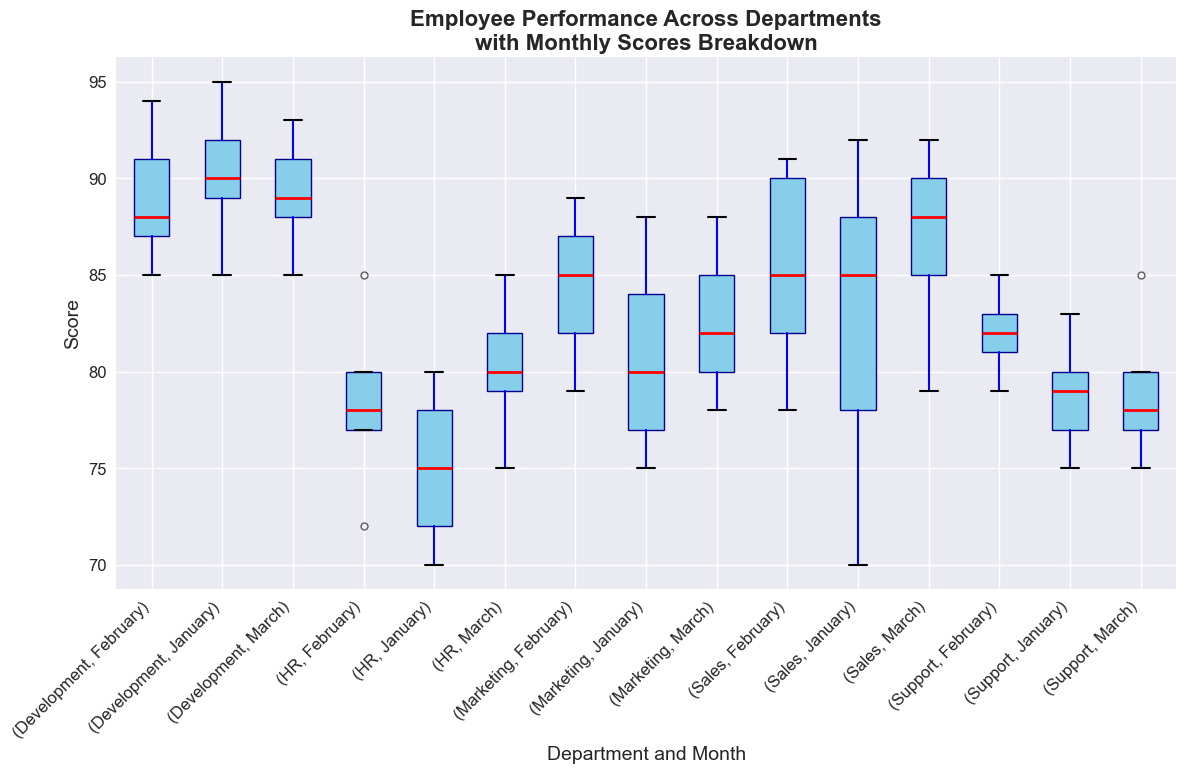Which department has the highest median score in January? By examining the boxplots for January, we can compare the median lines in each department's box. The Development department has the highest median because the red line representing the median is higher than those in other departments.
Answer: Development Which department shows the most consistent performance in March? Consistency can be inferred from the height of the box (representing the interquartile range). The HR department shows the most consistent performance in March as it has the shortest box, indicating the scores are closely packed.
Answer: HR Which department has the greatest range of scores in January? The range is visible by looking at the length between the whiskers of the boxplot. The Development department shows the greatest range in January since the whiskers span the widest distance.
Answer: Development How does the median score of Marketing in February compare to that of Sales in February? To compare, we look at the red median lines for both departments in February. Marketing's median score is slightly higher than Sales'.
Answer: Marketing's median is higher Which department has the lowest median score in March? We can determine the lowest median by finding the red median line positioned lowest on the y-axis for March. The Support department has the lowest median score in March.
Answer: Support Is the median score of HR higher in February or March? Comparing the red median lines for HR in February and March, the February median is lower than the March median.
Answer: March Which departmental score distribution has the widest interquartile range in any given month? The interquartile range is given by the height of the box itself, excluding the whiskers. The wide box in Development, January indicates the widest interquartile range.
Answer: Development, January Comparing Sales and Support in February, which one has a higher spread of scores? The spread can be analyzed by comparing the lengths between the whiskers of the boxplots. Sales has a wider spread of scores in February than Support.
Answer: Sales Which department's performance shows an improving trend from January to March? An improving trend is visible if the median line rises consistently from January to March. The Sales department shows such a trend as their median improves month over month.
Answer: Sales Is there any department that shows a decreasing performance from January to February? A decreasing performance is observed if the median line drops from January to February. The Support department shows a slight decrease from January to February.
Answer: Support 